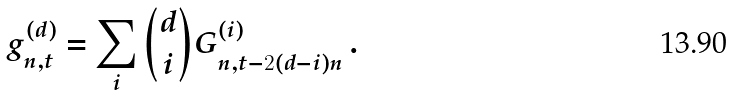Convert formula to latex. <formula><loc_0><loc_0><loc_500><loc_500>g _ { n , t } ^ { ( d ) } = \sum _ { i } { d \choose i } G _ { n , t - 2 ( d - i ) n } ^ { ( i ) } \, .</formula> 